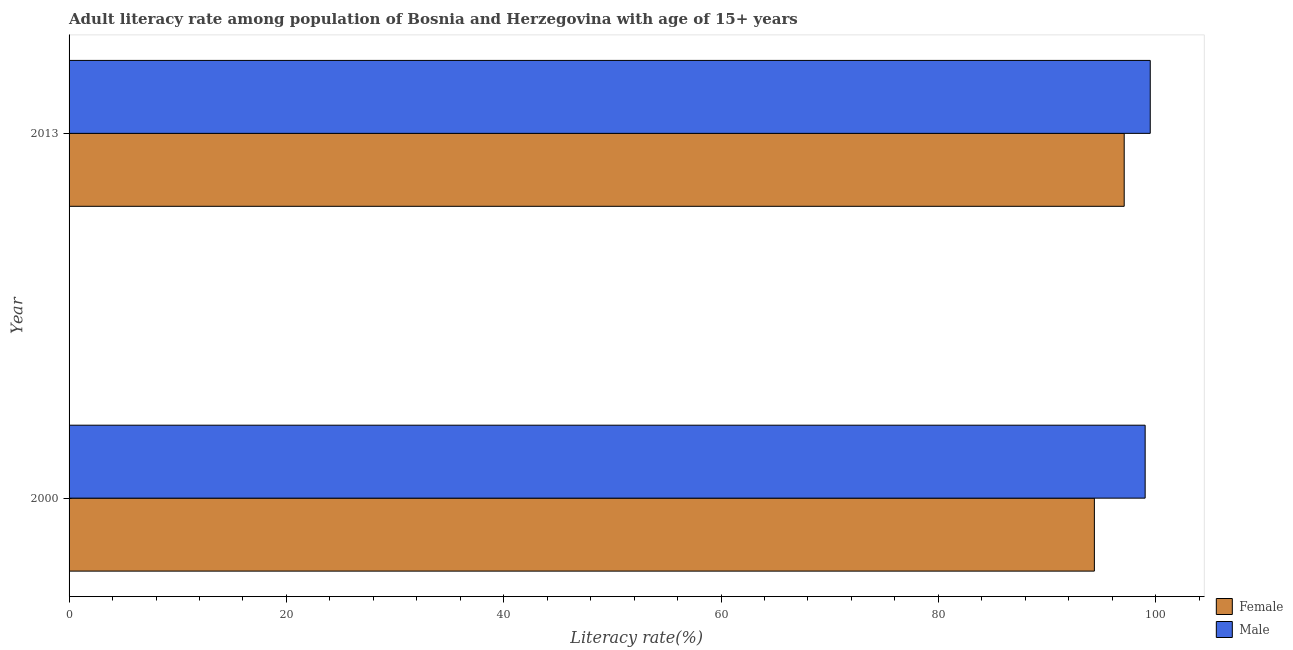How many different coloured bars are there?
Keep it short and to the point. 2. How many groups of bars are there?
Offer a terse response. 2. Are the number of bars on each tick of the Y-axis equal?
Your answer should be compact. Yes. What is the label of the 1st group of bars from the top?
Your answer should be very brief. 2013. What is the female adult literacy rate in 2000?
Give a very brief answer. 94.36. Across all years, what is the maximum female adult literacy rate?
Provide a succinct answer. 97.1. Across all years, what is the minimum male adult literacy rate?
Make the answer very short. 99.03. In which year was the female adult literacy rate maximum?
Keep it short and to the point. 2013. What is the total male adult literacy rate in the graph?
Ensure brevity in your answer.  198.54. What is the difference between the male adult literacy rate in 2000 and that in 2013?
Ensure brevity in your answer.  -0.47. What is the difference between the male adult literacy rate in 2000 and the female adult literacy rate in 2013?
Keep it short and to the point. 1.93. What is the average male adult literacy rate per year?
Your response must be concise. 99.27. In the year 2000, what is the difference between the male adult literacy rate and female adult literacy rate?
Your answer should be compact. 4.67. In how many years, is the male adult literacy rate greater than 60 %?
Give a very brief answer. 2. What is the ratio of the male adult literacy rate in 2000 to that in 2013?
Ensure brevity in your answer.  0.99. What does the 2nd bar from the bottom in 2013 represents?
Provide a short and direct response. Male. What is the difference between two consecutive major ticks on the X-axis?
Your response must be concise. 20. Are the values on the major ticks of X-axis written in scientific E-notation?
Keep it short and to the point. No. Does the graph contain grids?
Offer a very short reply. No. What is the title of the graph?
Your answer should be compact. Adult literacy rate among population of Bosnia and Herzegovina with age of 15+ years. What is the label or title of the X-axis?
Provide a succinct answer. Literacy rate(%). What is the Literacy rate(%) of Female in 2000?
Keep it short and to the point. 94.36. What is the Literacy rate(%) in Male in 2000?
Your response must be concise. 99.03. What is the Literacy rate(%) in Female in 2013?
Offer a very short reply. 97.1. What is the Literacy rate(%) in Male in 2013?
Offer a terse response. 99.5. Across all years, what is the maximum Literacy rate(%) in Female?
Provide a succinct answer. 97.1. Across all years, what is the maximum Literacy rate(%) of Male?
Keep it short and to the point. 99.5. Across all years, what is the minimum Literacy rate(%) of Female?
Keep it short and to the point. 94.36. Across all years, what is the minimum Literacy rate(%) of Male?
Your answer should be very brief. 99.03. What is the total Literacy rate(%) of Female in the graph?
Your response must be concise. 191.46. What is the total Literacy rate(%) of Male in the graph?
Your answer should be very brief. 198.54. What is the difference between the Literacy rate(%) of Female in 2000 and that in 2013?
Offer a very short reply. -2.74. What is the difference between the Literacy rate(%) in Male in 2000 and that in 2013?
Your response must be concise. -0.47. What is the difference between the Literacy rate(%) of Female in 2000 and the Literacy rate(%) of Male in 2013?
Your answer should be compact. -5.14. What is the average Literacy rate(%) in Female per year?
Offer a terse response. 95.73. What is the average Literacy rate(%) in Male per year?
Ensure brevity in your answer.  99.27. In the year 2000, what is the difference between the Literacy rate(%) of Female and Literacy rate(%) of Male?
Your answer should be very brief. -4.67. In the year 2013, what is the difference between the Literacy rate(%) of Female and Literacy rate(%) of Male?
Ensure brevity in your answer.  -2.4. What is the ratio of the Literacy rate(%) of Female in 2000 to that in 2013?
Provide a succinct answer. 0.97. What is the difference between the highest and the second highest Literacy rate(%) of Female?
Offer a terse response. 2.74. What is the difference between the highest and the second highest Literacy rate(%) of Male?
Your answer should be very brief. 0.47. What is the difference between the highest and the lowest Literacy rate(%) in Female?
Your response must be concise. 2.74. What is the difference between the highest and the lowest Literacy rate(%) of Male?
Ensure brevity in your answer.  0.47. 